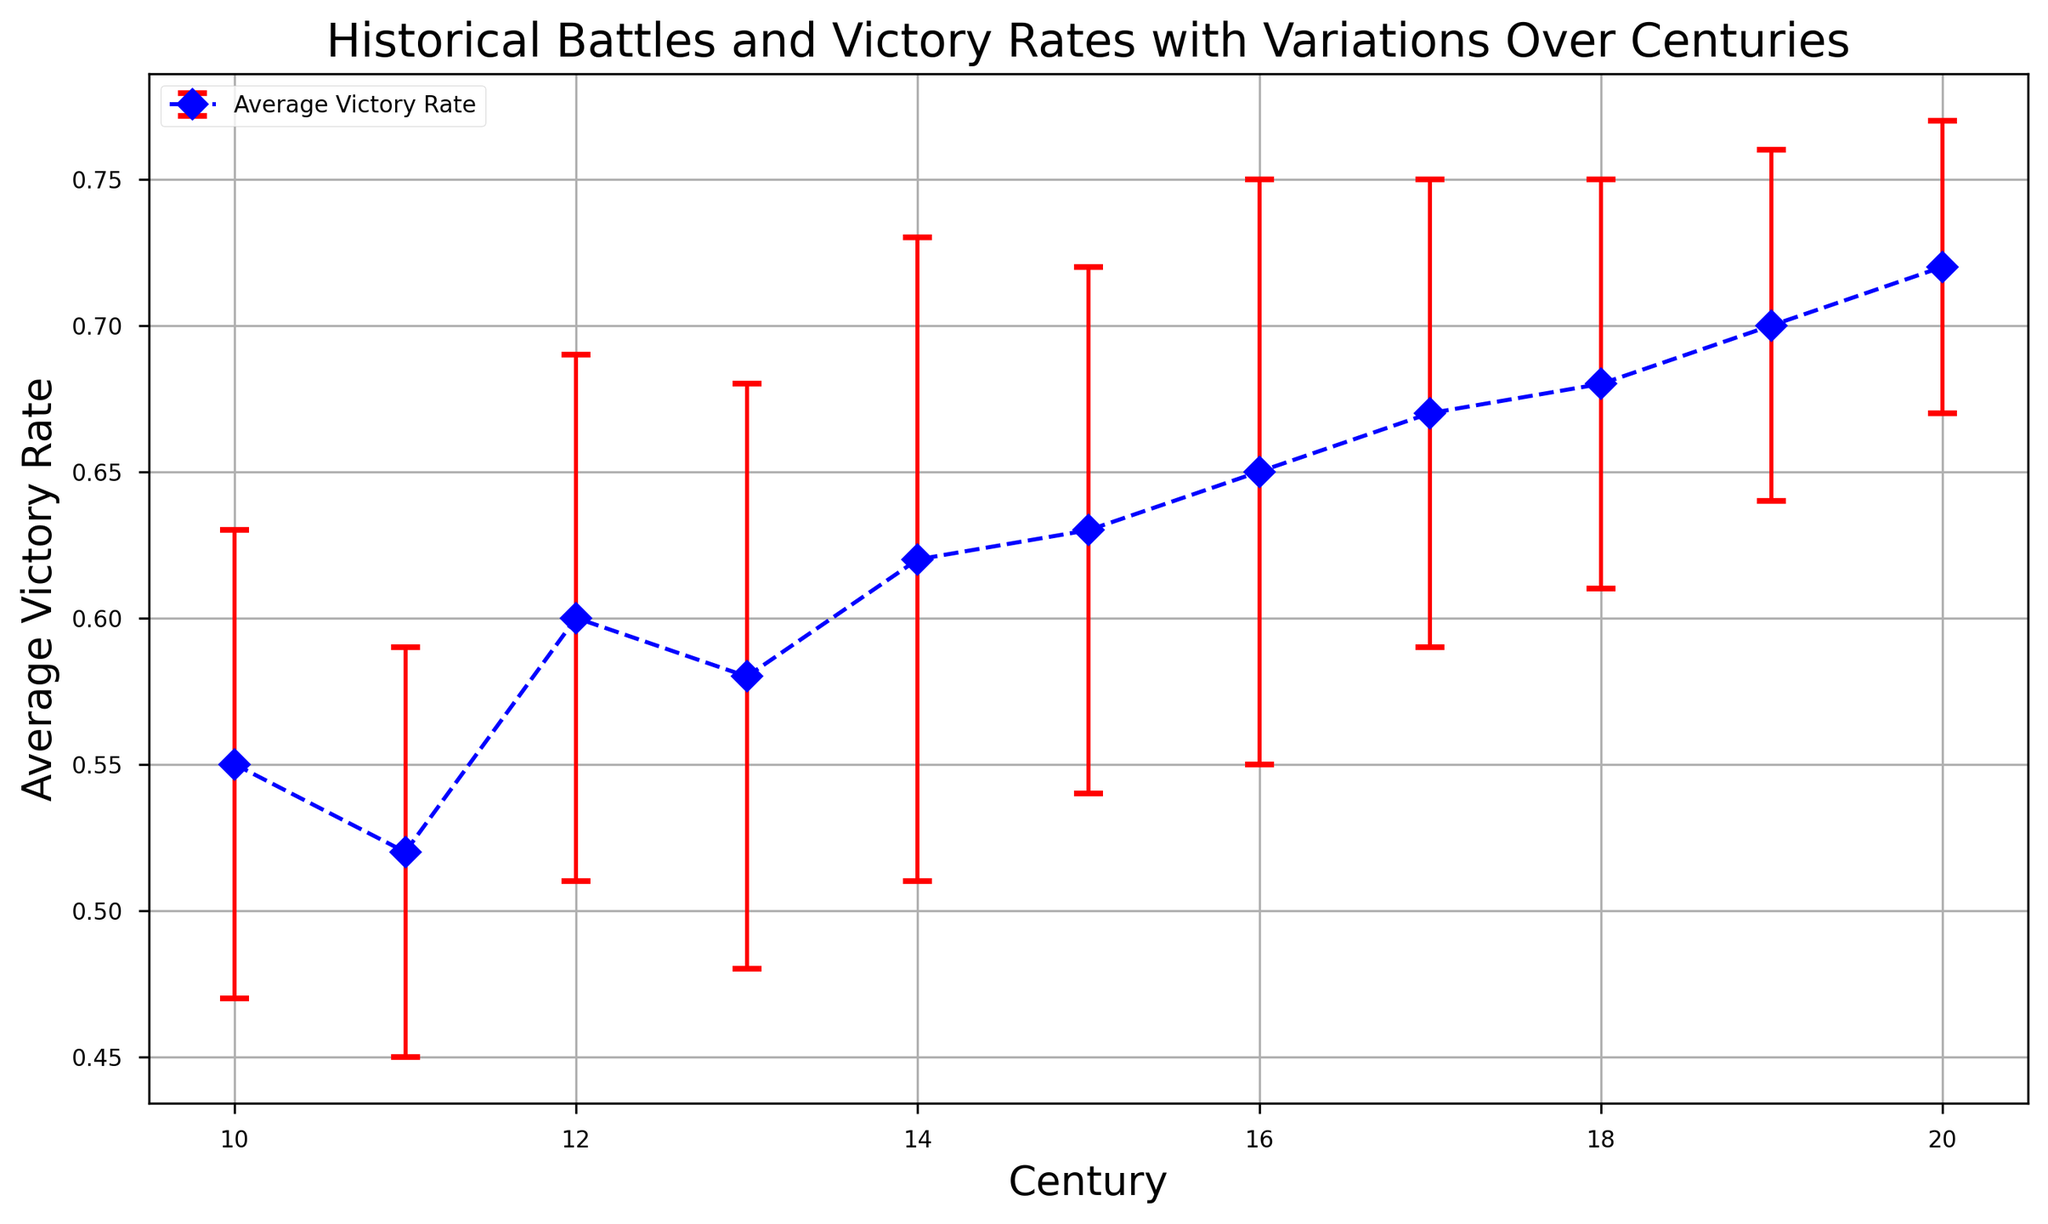What is the average victory rate in the 18th century? Locate the data point for the 18th century (Century = 18). The Average Victory Rate associated with it is 0.68.
Answer: 0.68 Which century has the highest average victory rate? Scan through the average victory rates for each century displayed on the plot. The highest average victory rate is 0.72 in the 20th century.
Answer: 20th century How does the average victory rate change from the 10th century to the 20th century? Look at the average victory rates for the 10th (.55) and 20th (.72) centuries. Calculate the change: 0.72 - 0.55 = 0.17.
Answer: Increase by 0.17 Which century has the highest standard deviation in victory rate? Examine the error bars to identify the largest vertical line, corresponding to the standard deviation. The 14th century has the largest error bar with a Victory Rate STD of 0.11.
Answer: 14th century What is the general trend in average victory rates over the centuries? Observe the overall pattern of the average victory rates from the 10th to 20th centuries. There is a general increasing trend in the average victory rates.
Answer: Increasing trend Are there any centuries where the average victory rate is stable or doesn't change significantly? Analyze the points where the victory rates remain quite similar across consecutive centuries. The 17th and 18th centuries have close average victory rates (0.67 and 0.68).
Answer: 17th and 18th centuries What is the range of the average victory rates throughout the recorded centuries? Identify the smallest and largest average victory rates in the dataset. The smallest is 0.52 (11th century) and the largest is 0.72 (20th century). The range is 0.72 - 0.52 = 0.20.
Answer: 0.20 Considering the error bars, which century demonstrates the most uncertain victory rate? The century with the highest standard deviation (largest error bar) indicates the most uncertainty. The 14th century’s error bar has the highest standard deviation (0.11).
Answer: 14th century How does the greatest change in standard deviation from one century to the next manifest? Compare the standard deviations between consecutive centuries to find the maximum change. Between the 13th and 14th centuries, the standard deviation changes from 0.10 to 0.11, an increase of 0.01.
Answer: Increase of 0.01 between 13th and 14th centuries 